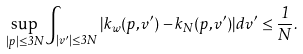<formula> <loc_0><loc_0><loc_500><loc_500>\sup _ { | p | \leq 3 N } \int _ { | v ^ { \prime } | \leq 3 N } | k _ { w } ( p , v ^ { \prime } ) - k _ { N } ( p , v ^ { \prime } ) | d v ^ { \prime } \leq \frac { 1 } { N } .</formula> 